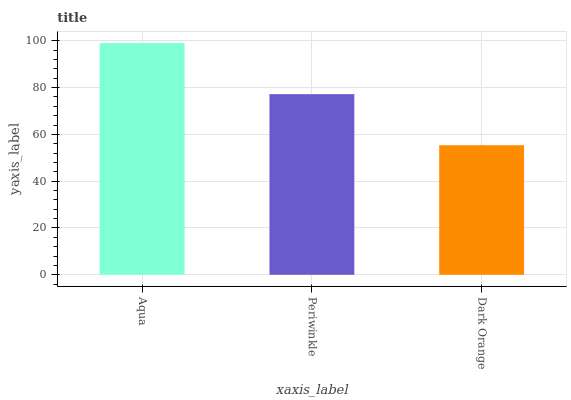Is Dark Orange the minimum?
Answer yes or no. Yes. Is Aqua the maximum?
Answer yes or no. Yes. Is Periwinkle the minimum?
Answer yes or no. No. Is Periwinkle the maximum?
Answer yes or no. No. Is Aqua greater than Periwinkle?
Answer yes or no. Yes. Is Periwinkle less than Aqua?
Answer yes or no. Yes. Is Periwinkle greater than Aqua?
Answer yes or no. No. Is Aqua less than Periwinkle?
Answer yes or no. No. Is Periwinkle the high median?
Answer yes or no. Yes. Is Periwinkle the low median?
Answer yes or no. Yes. Is Dark Orange the high median?
Answer yes or no. No. Is Dark Orange the low median?
Answer yes or no. No. 